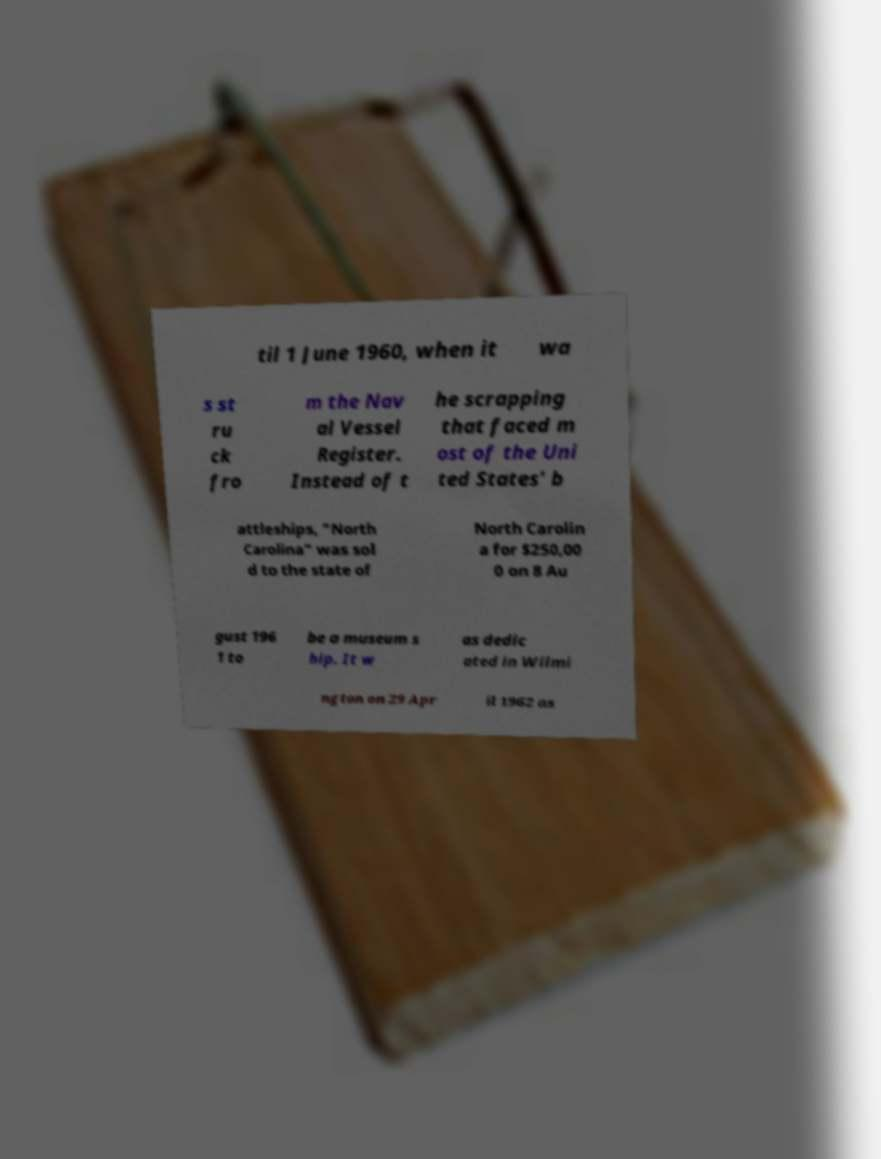I need the written content from this picture converted into text. Can you do that? til 1 June 1960, when it wa s st ru ck fro m the Nav al Vessel Register. Instead of t he scrapping that faced m ost of the Uni ted States' b attleships, "North Carolina" was sol d to the state of North Carolin a for $250,00 0 on 8 Au gust 196 1 to be a museum s hip. It w as dedic ated in Wilmi ngton on 29 Apr il 1962 as 